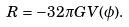<formula> <loc_0><loc_0><loc_500><loc_500>R = - 3 2 \pi G V ( \phi ) .</formula> 